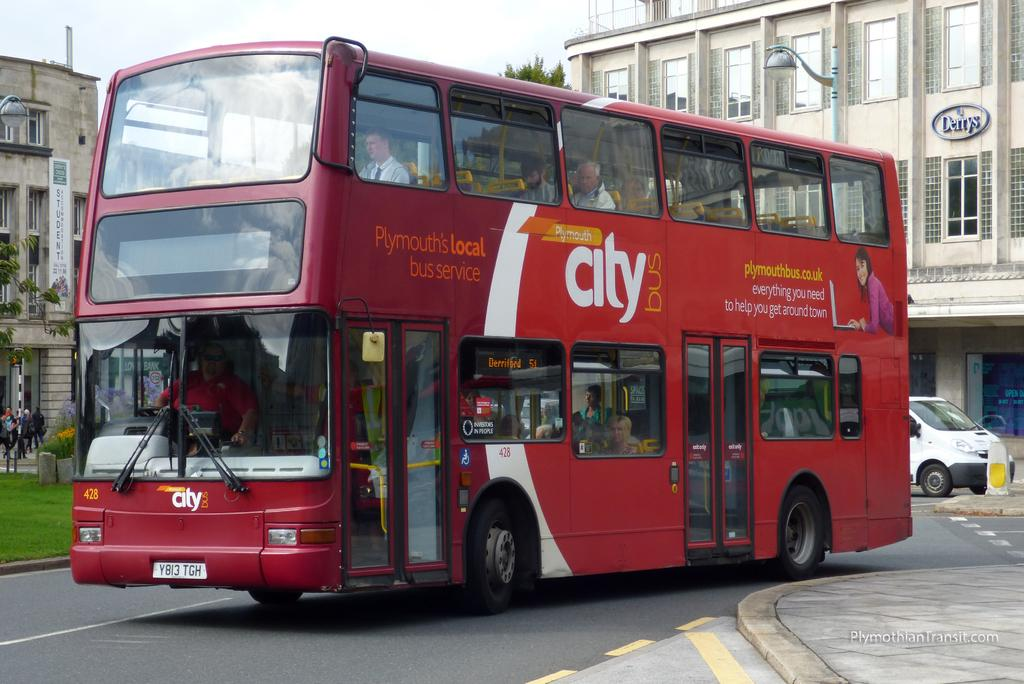Provide a one-sentence caption for the provided image. a double decker Plymouth's Local city bus service bus saying everything you need to get around town. 